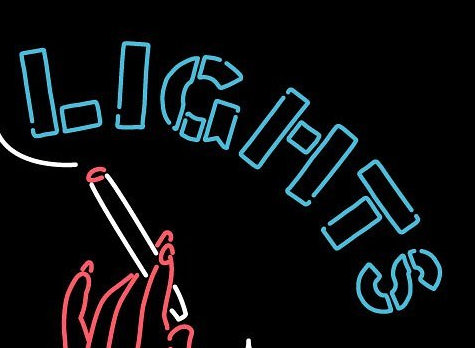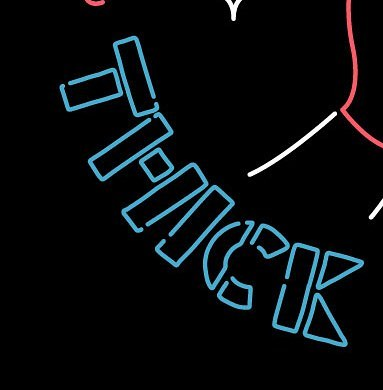What text is displayed in these images sequentially, separated by a semicolon? LIGHTS; THICK 